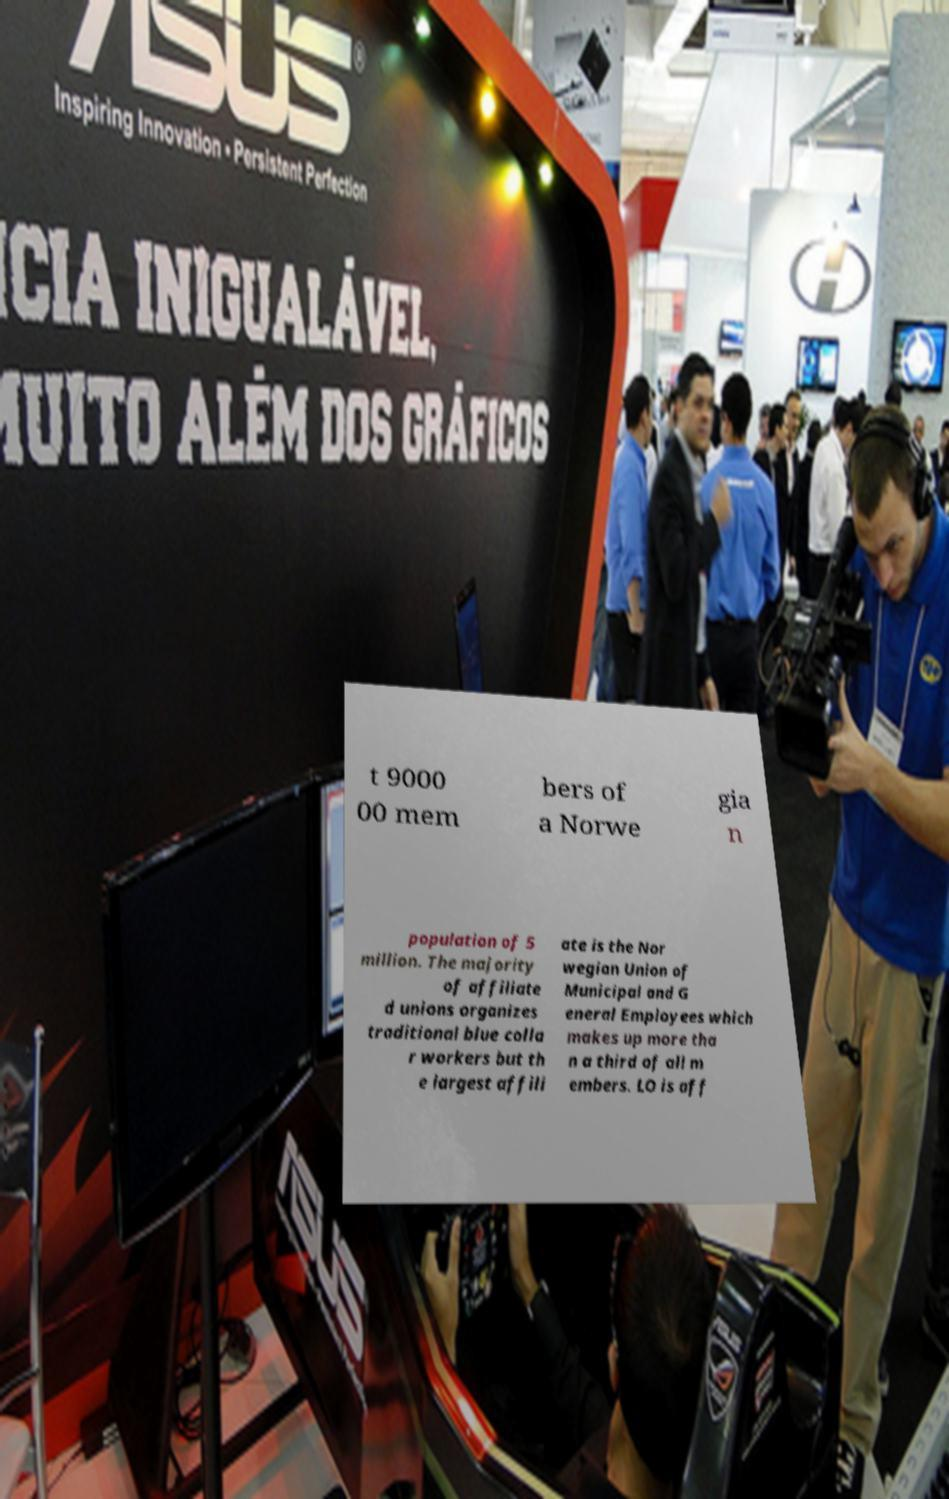Could you assist in decoding the text presented in this image and type it out clearly? t 9000 00 mem bers of a Norwe gia n population of 5 million. The majority of affiliate d unions organizes traditional blue colla r workers but th e largest affili ate is the Nor wegian Union of Municipal and G eneral Employees which makes up more tha n a third of all m embers. LO is aff 